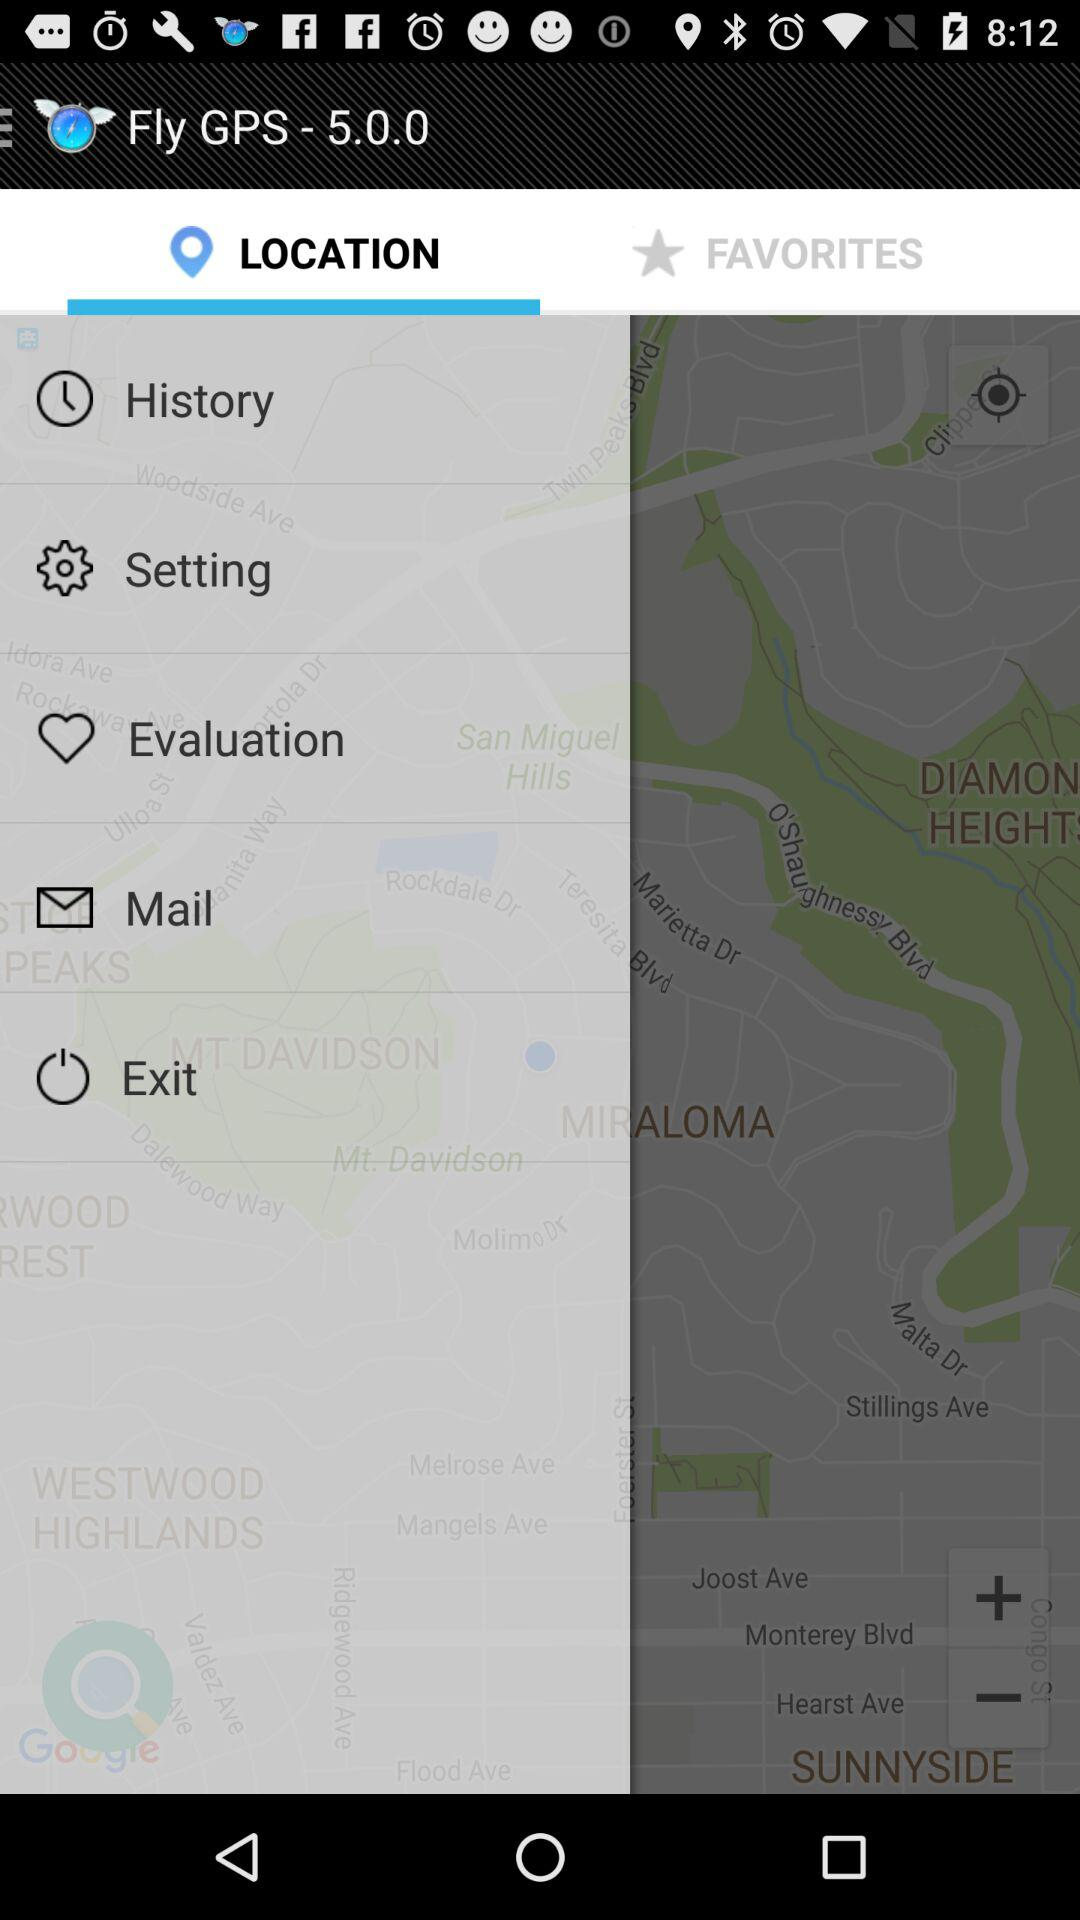What is the application name? The application name is "Fly GPS". 